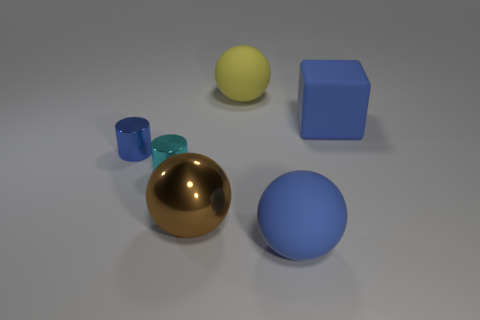What colors can you identify in the objects shown in the image? In the image, there are objects in gold, blue, yellow, and two shades of teal. 